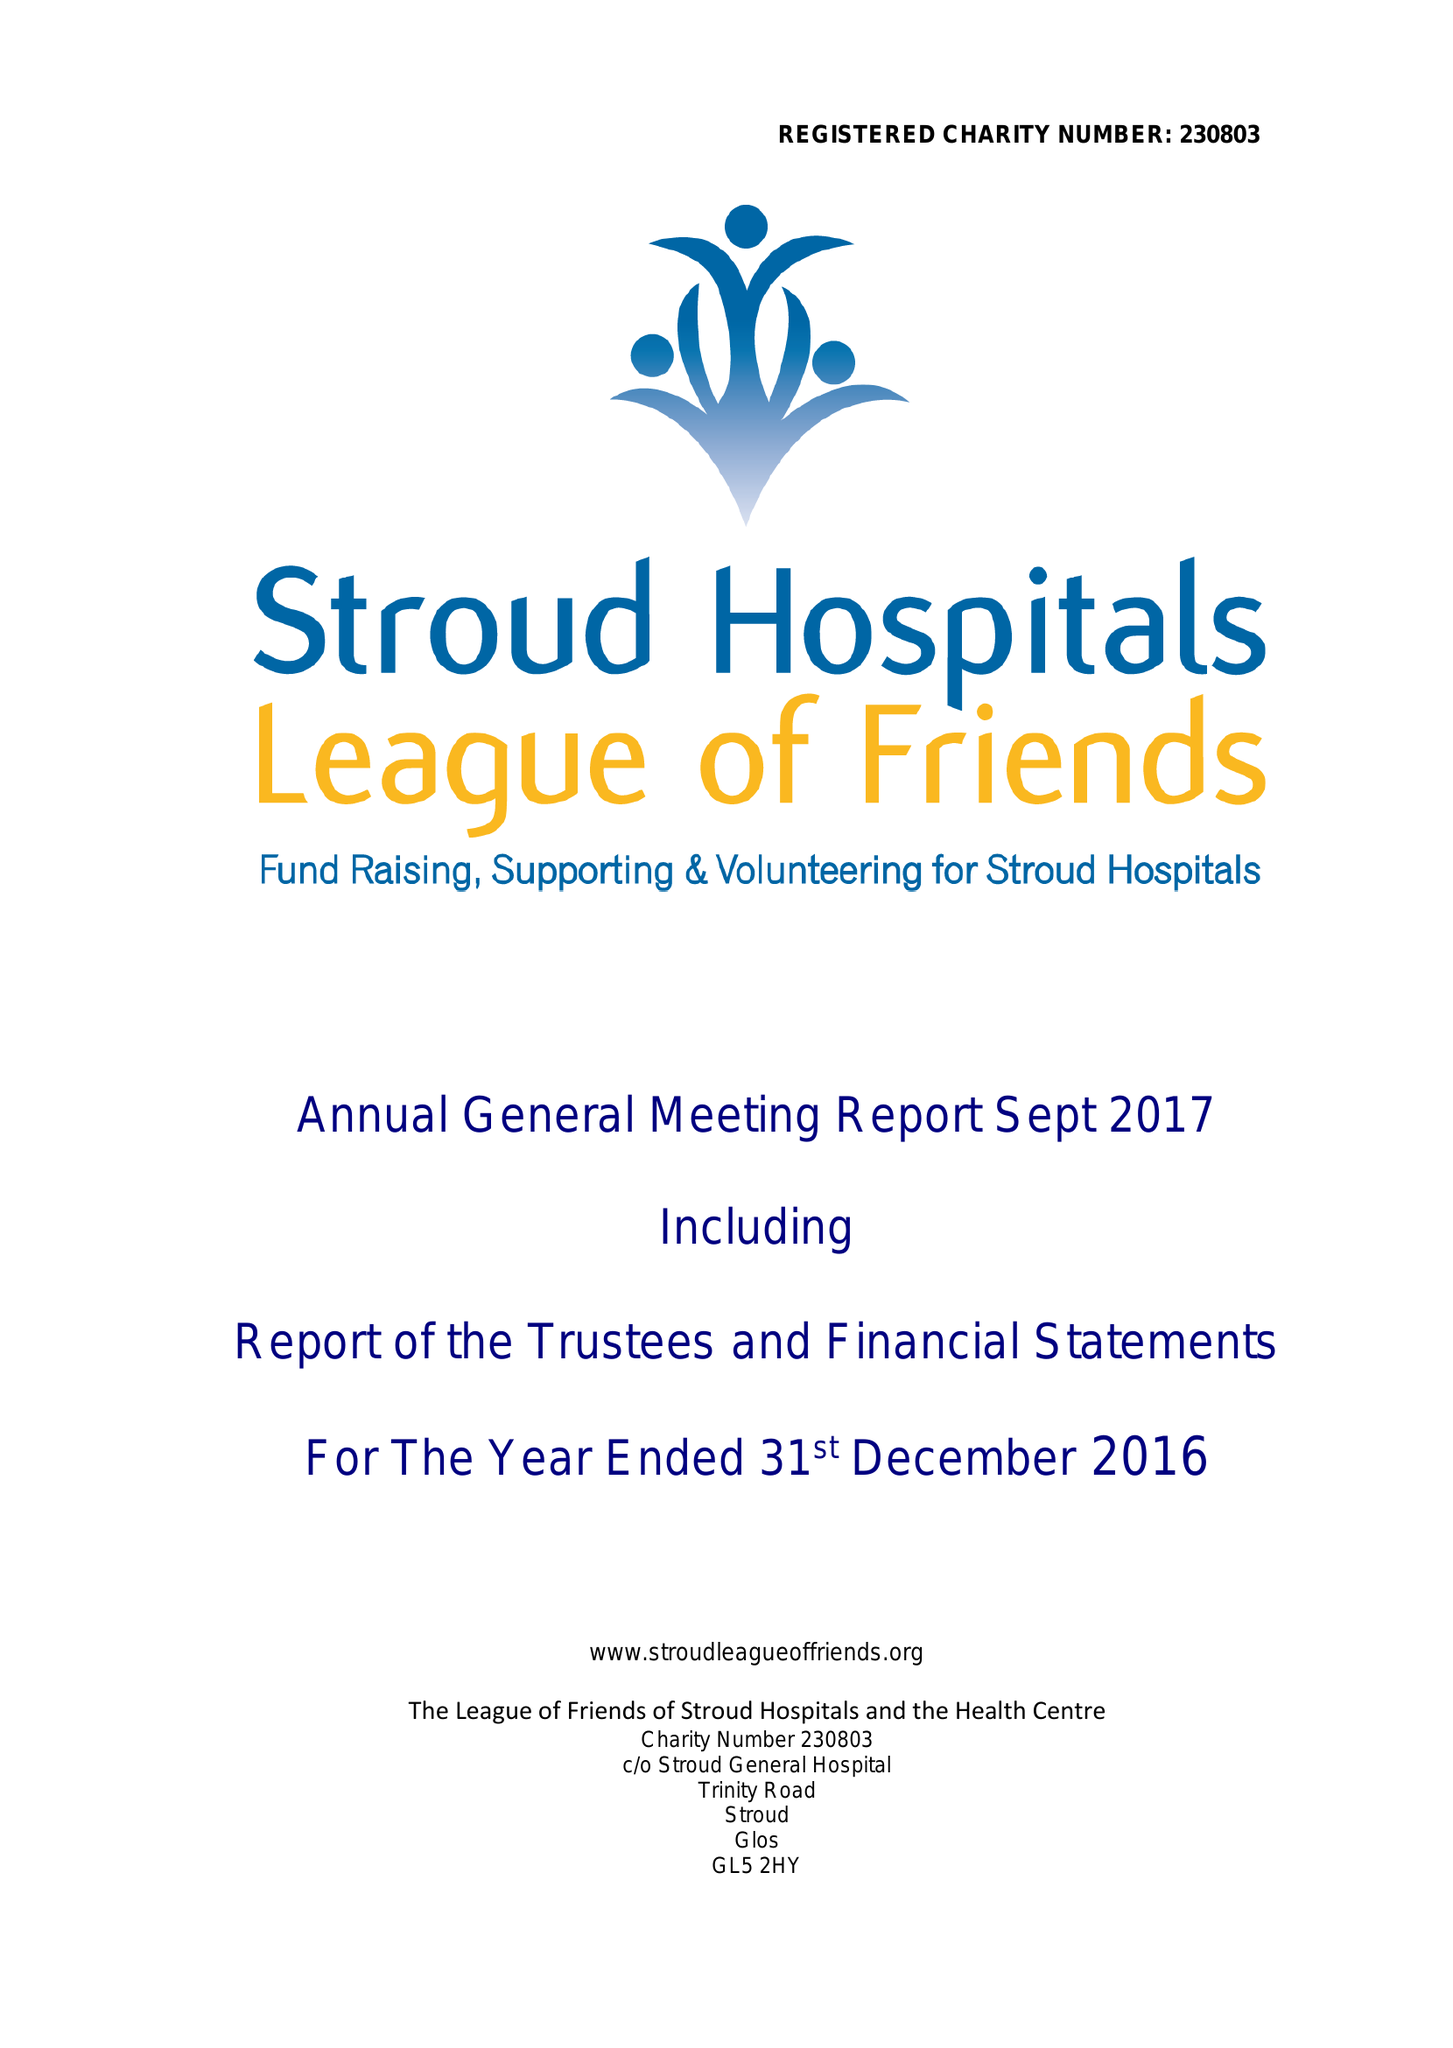What is the value for the address__postcode?
Answer the question using a single word or phrase. GL5 2HY 